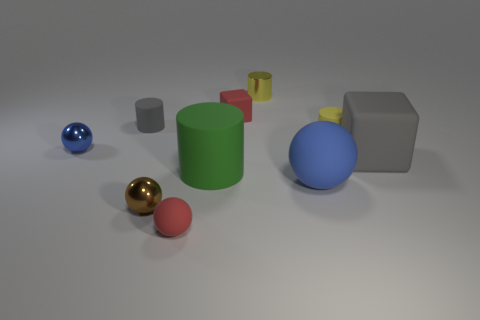Are there more tiny brown spheres that are to the right of the tiny brown shiny sphere than things in front of the large rubber cylinder?
Provide a short and direct response. No. There is a gray cube that is the same size as the green rubber object; what is it made of?
Your answer should be compact. Rubber. What shape is the brown object?
Give a very brief answer. Sphere. What number of blue things are small spheres or metal things?
Offer a very short reply. 1. What is the size of the gray block that is the same material as the green cylinder?
Your response must be concise. Large. Does the cylinder in front of the gray cube have the same material as the gray object that is in front of the tiny gray rubber cylinder?
Your answer should be very brief. Yes. What number of spheres are either small gray things or blue metallic objects?
Keep it short and to the point. 1. How many large matte cylinders are on the left side of the tiny red object that is behind the gray object that is behind the large matte cube?
Your response must be concise. 1. What is the material of the other big object that is the same shape as the yellow shiny object?
Your answer should be very brief. Rubber. Is there any other thing that is the same material as the small gray cylinder?
Ensure brevity in your answer.  Yes. 